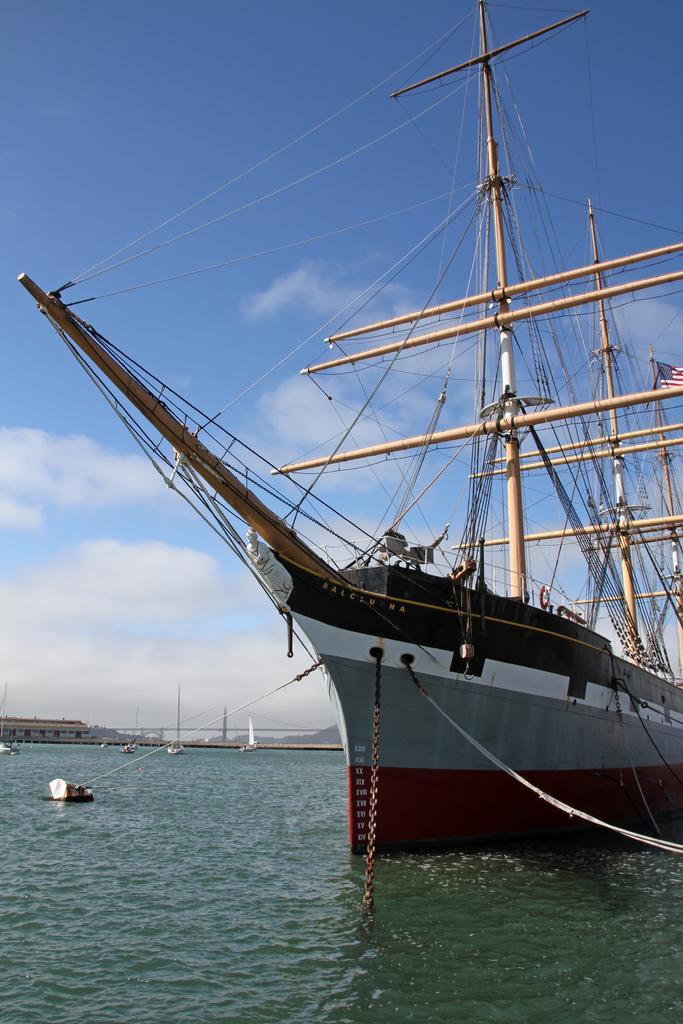In one or two sentences, can you explain what this image depicts? In this picture I can see the water and I see a ship in front, on which there are poles and wires and on the right side of this image I see a flag. In the background I see the clear sky. 